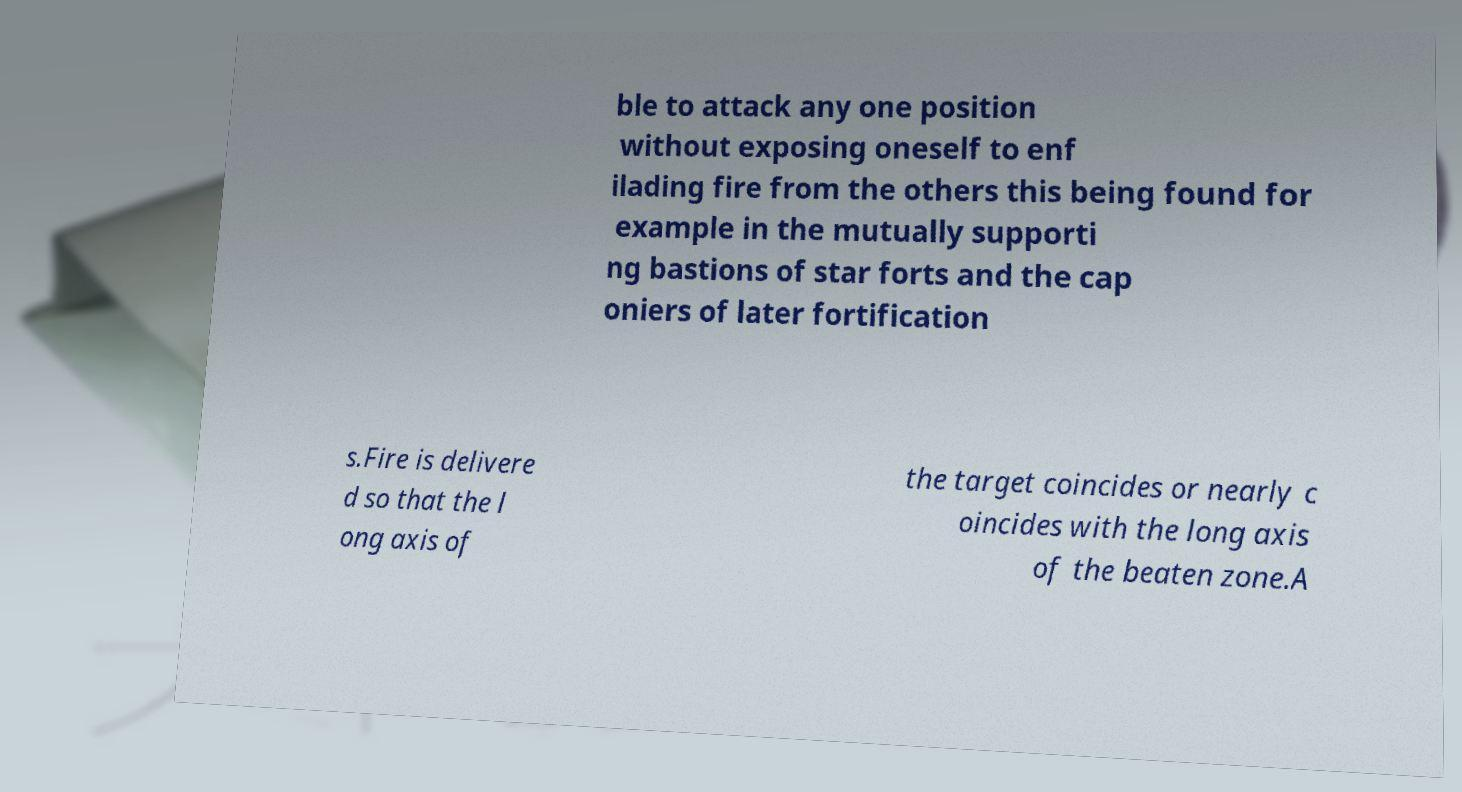For documentation purposes, I need the text within this image transcribed. Could you provide that? ble to attack any one position without exposing oneself to enf ilading fire from the others this being found for example in the mutually supporti ng bastions of star forts and the cap oniers of later fortification s.Fire is delivere d so that the l ong axis of the target coincides or nearly c oincides with the long axis of the beaten zone.A 